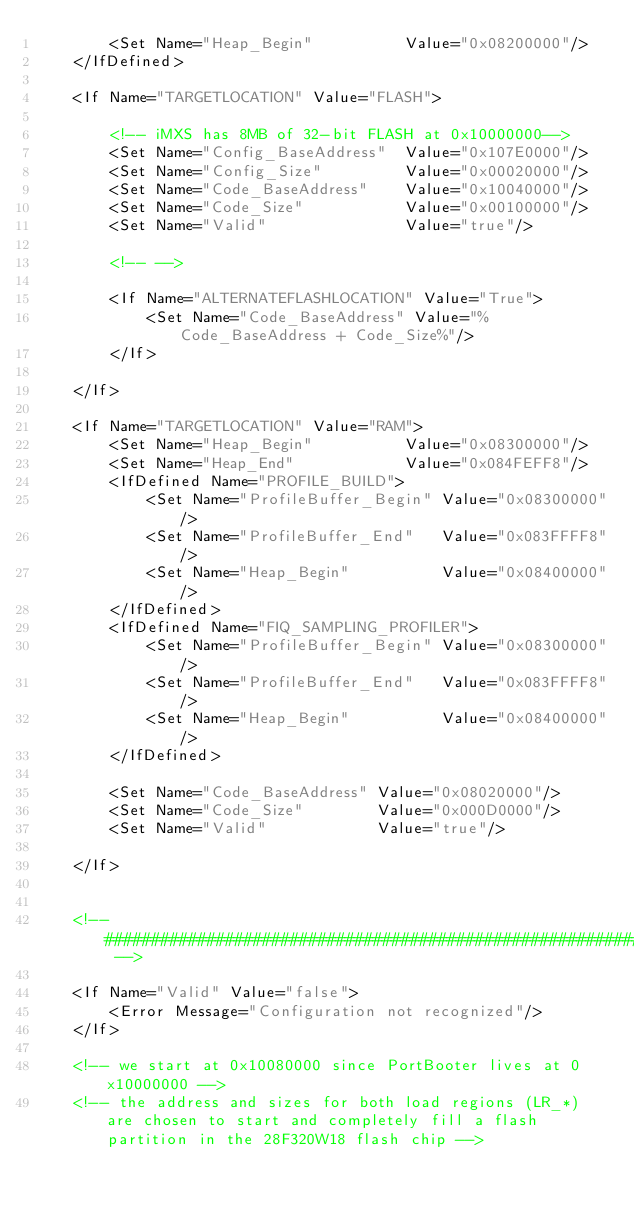Convert code to text. <code><loc_0><loc_0><loc_500><loc_500><_XML_>        <Set Name="Heap_Begin"          Value="0x08200000"/>
    </IfDefined>

    <If Name="TARGETLOCATION" Value="FLASH">
    
        <!-- iMXS has 8MB of 32-bit FLASH at 0x10000000-->
        <Set Name="Config_BaseAddress"  Value="0x107E0000"/>    
        <Set Name="Config_Size"         Value="0x00020000"/>
        <Set Name="Code_BaseAddress"    Value="0x10040000"/>
        <Set Name="Code_Size"           Value="0x00100000"/>
        <Set Name="Valid"               Value="true"/>

        <!-- -->
        
        <If Name="ALTERNATEFLASHLOCATION" Value="True">
            <Set Name="Code_BaseAddress" Value="%Code_BaseAddress + Code_Size%"/>
        </If>

    </If>

    <If Name="TARGETLOCATION" Value="RAM">
        <Set Name="Heap_Begin"          Value="0x08300000"/>
        <Set Name="Heap_End"            Value="0x084FEFF8"/>
        <IfDefined Name="PROFILE_BUILD">
            <Set Name="ProfileBuffer_Begin" Value="0x08300000"/>
            <Set Name="ProfileBuffer_End"   Value="0x083FFFF8"/>
            <Set Name="Heap_Begin"          Value="0x08400000"/>
        </IfDefined>
        <IfDefined Name="FIQ_SAMPLING_PROFILER">
            <Set Name="ProfileBuffer_Begin" Value="0x08300000"/>
            <Set Name="ProfileBuffer_End"   Value="0x083FFFF8"/>
            <Set Name="Heap_Begin"          Value="0x08400000"/>
        </IfDefined>

        <Set Name="Code_BaseAddress" Value="0x08020000"/>
        <Set Name="Code_Size"        Value="0x000D0000"/>
        <Set Name="Valid"            Value="true"/>

    </If>


    <!-- ################################################################################ -->

    <If Name="Valid" Value="false">
        <Error Message="Configuration not recognized"/>
    </If>

    <!-- we start at 0x10080000 since PortBooter lives at 0x10000000 -->
    <!-- the address and sizes for both load regions (LR_*) are chosen to start and completely fill a flash partition in the 28F320W18 flash chip -->
</code> 